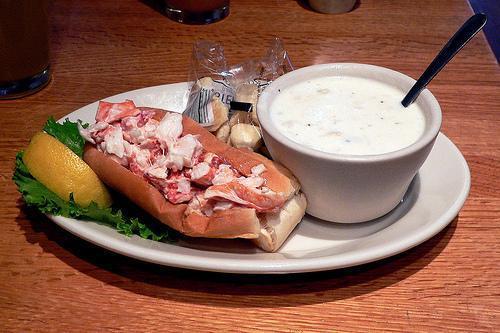How many plates of food are on the table?
Give a very brief answer. 1. 